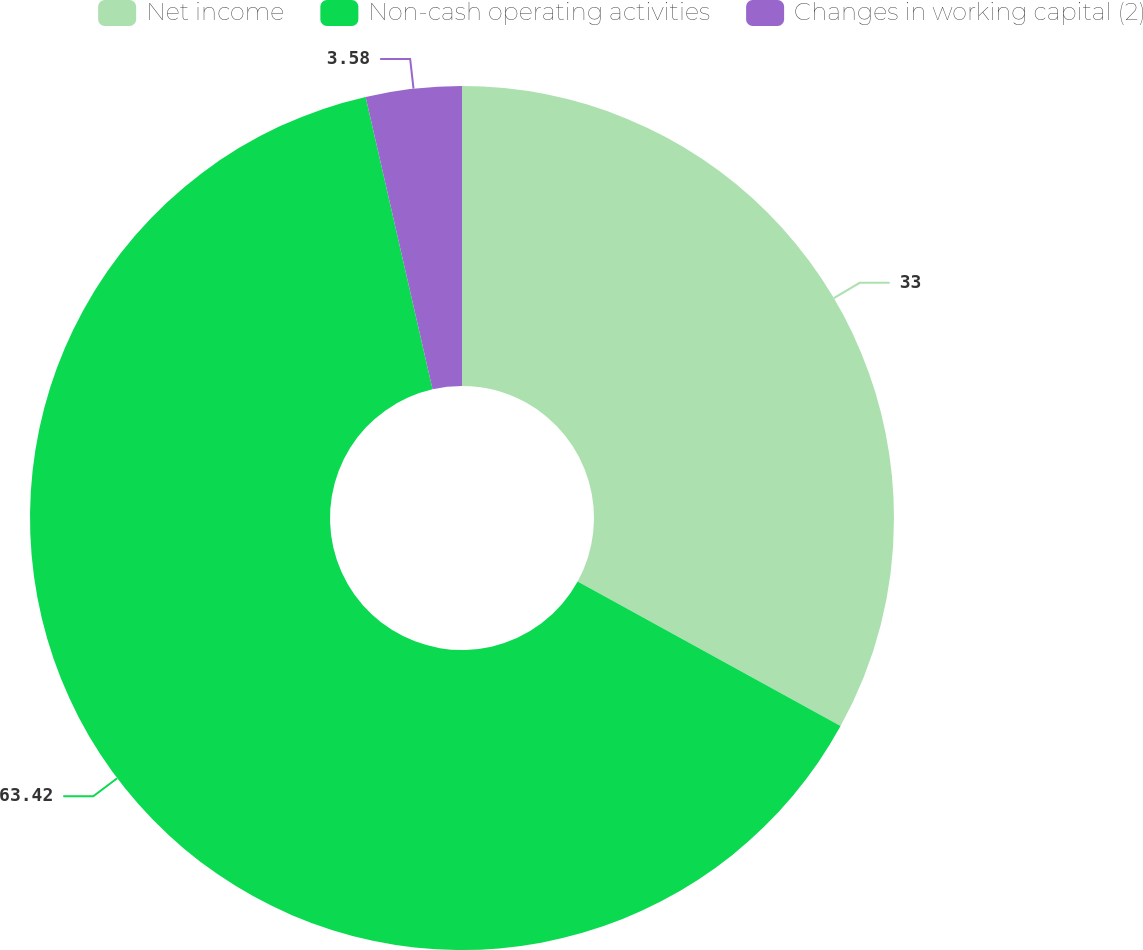Convert chart. <chart><loc_0><loc_0><loc_500><loc_500><pie_chart><fcel>Net income<fcel>Non-cash operating activities<fcel>Changes in working capital (2)<nl><fcel>33.0%<fcel>63.42%<fcel>3.58%<nl></chart> 